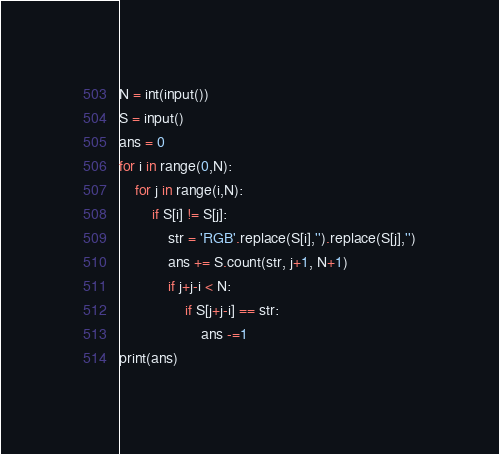<code> <loc_0><loc_0><loc_500><loc_500><_Python_>N = int(input())
S = input()
ans = 0
for i in range(0,N):
    for j in range(i,N):
        if S[i] != S[j]:
            str = 'RGB'.replace(S[i],'').replace(S[j],'')
            ans += S.count(str, j+1, N+1)
            if j+j-i < N:
                if S[j+j-i] == str:
                    ans -=1
print(ans)</code> 